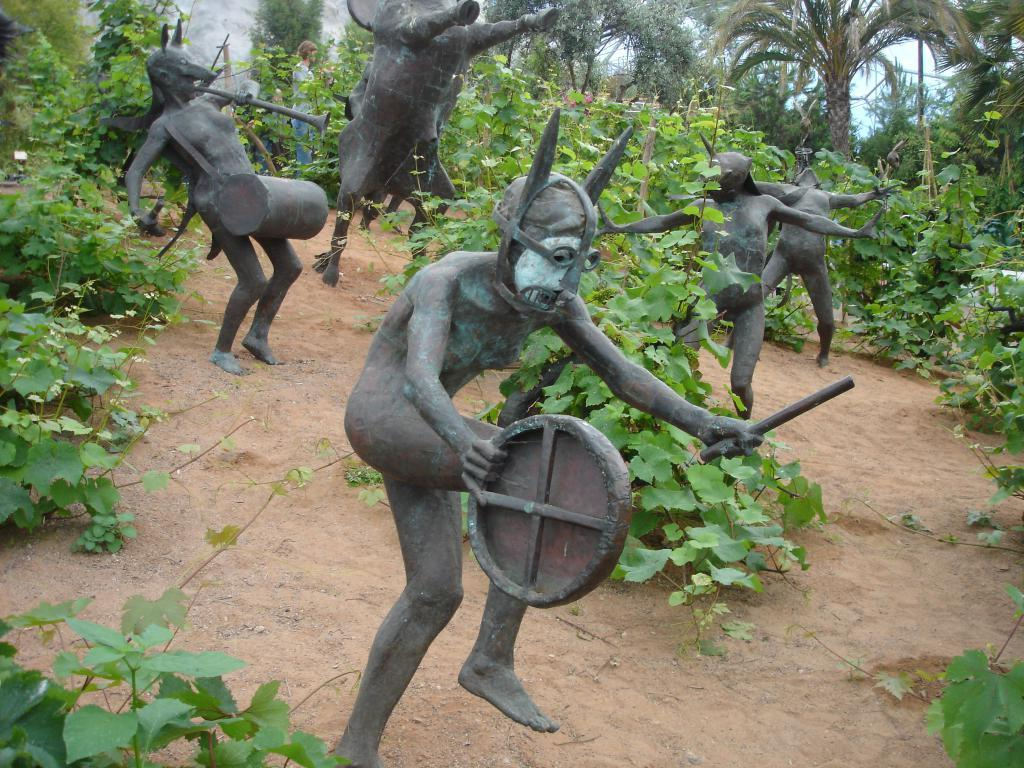What type of objects can be seen in the image? There are statues in the image. What else can be seen in the image besides the statues? There are plants in the image. What can be seen in the background of the image? There are trees in the background of the image. How many pages are visible in the image? There are no pages present in the image; it features statues, plants, and trees. What type of seed can be seen growing on the statues in the image? There are no seeds visible on the statues in the image. 